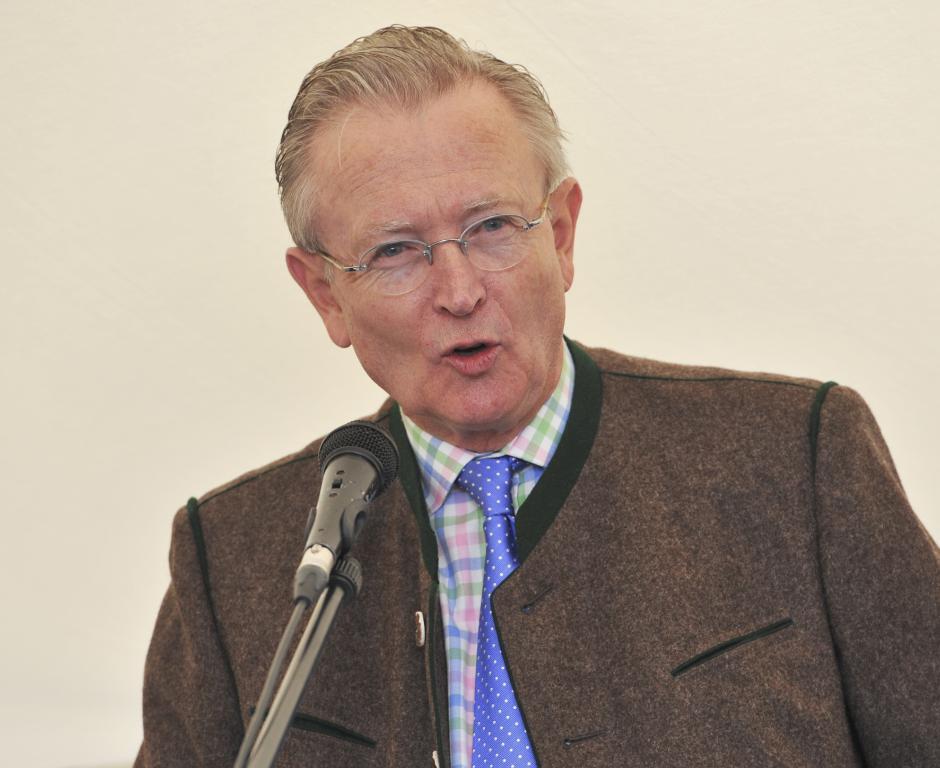How would you summarize this image in a sentence or two? In the foreground of this image, there is a man wearing coat is standing in front of a mic and there is a cream background. 